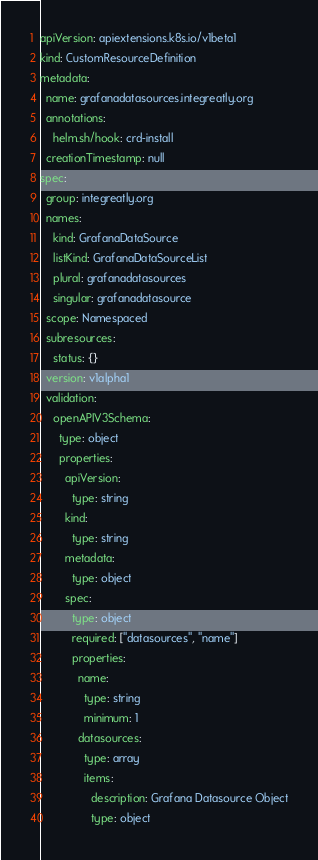<code> <loc_0><loc_0><loc_500><loc_500><_YAML_>apiVersion: apiextensions.k8s.io/v1beta1
kind: CustomResourceDefinition
metadata:
  name: grafanadatasources.integreatly.org
  annotations:
    helm.sh/hook: crd-install
  creationTimestamp: null
spec:
  group: integreatly.org
  names:
    kind: GrafanaDataSource
    listKind: GrafanaDataSourceList
    plural: grafanadatasources
    singular: grafanadatasource
  scope: Namespaced
  subresources:
    status: {}
  version: v1alpha1
  validation:
    openAPIV3Schema:
      type: object
      properties:
        apiVersion:
          type: string
        kind:
          type: string
        metadata:
          type: object
        spec:
          type: object
          required: ["datasources", "name"]
          properties:
            name:
              type: string
              minimum: 1
            datasources:
              type: array
              items:
                description: Grafana Datasource Object
                type: object
</code> 